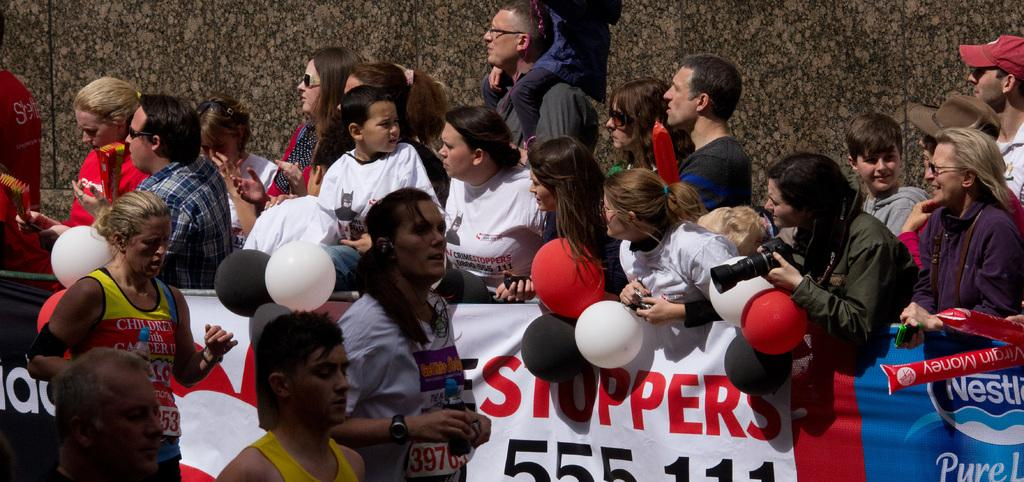Who or what can be seen in the image? There are people in the image. What are the people doing in the image? The people are holding objects in their hands. Can you describe the arrangement of the posters in the image? There are posters in the image, arranged from left to right. What type of substance can be seen growing in the garden in the image? There is no garden present in the image, so it is not possible to determine what type of substance might be growing there. 